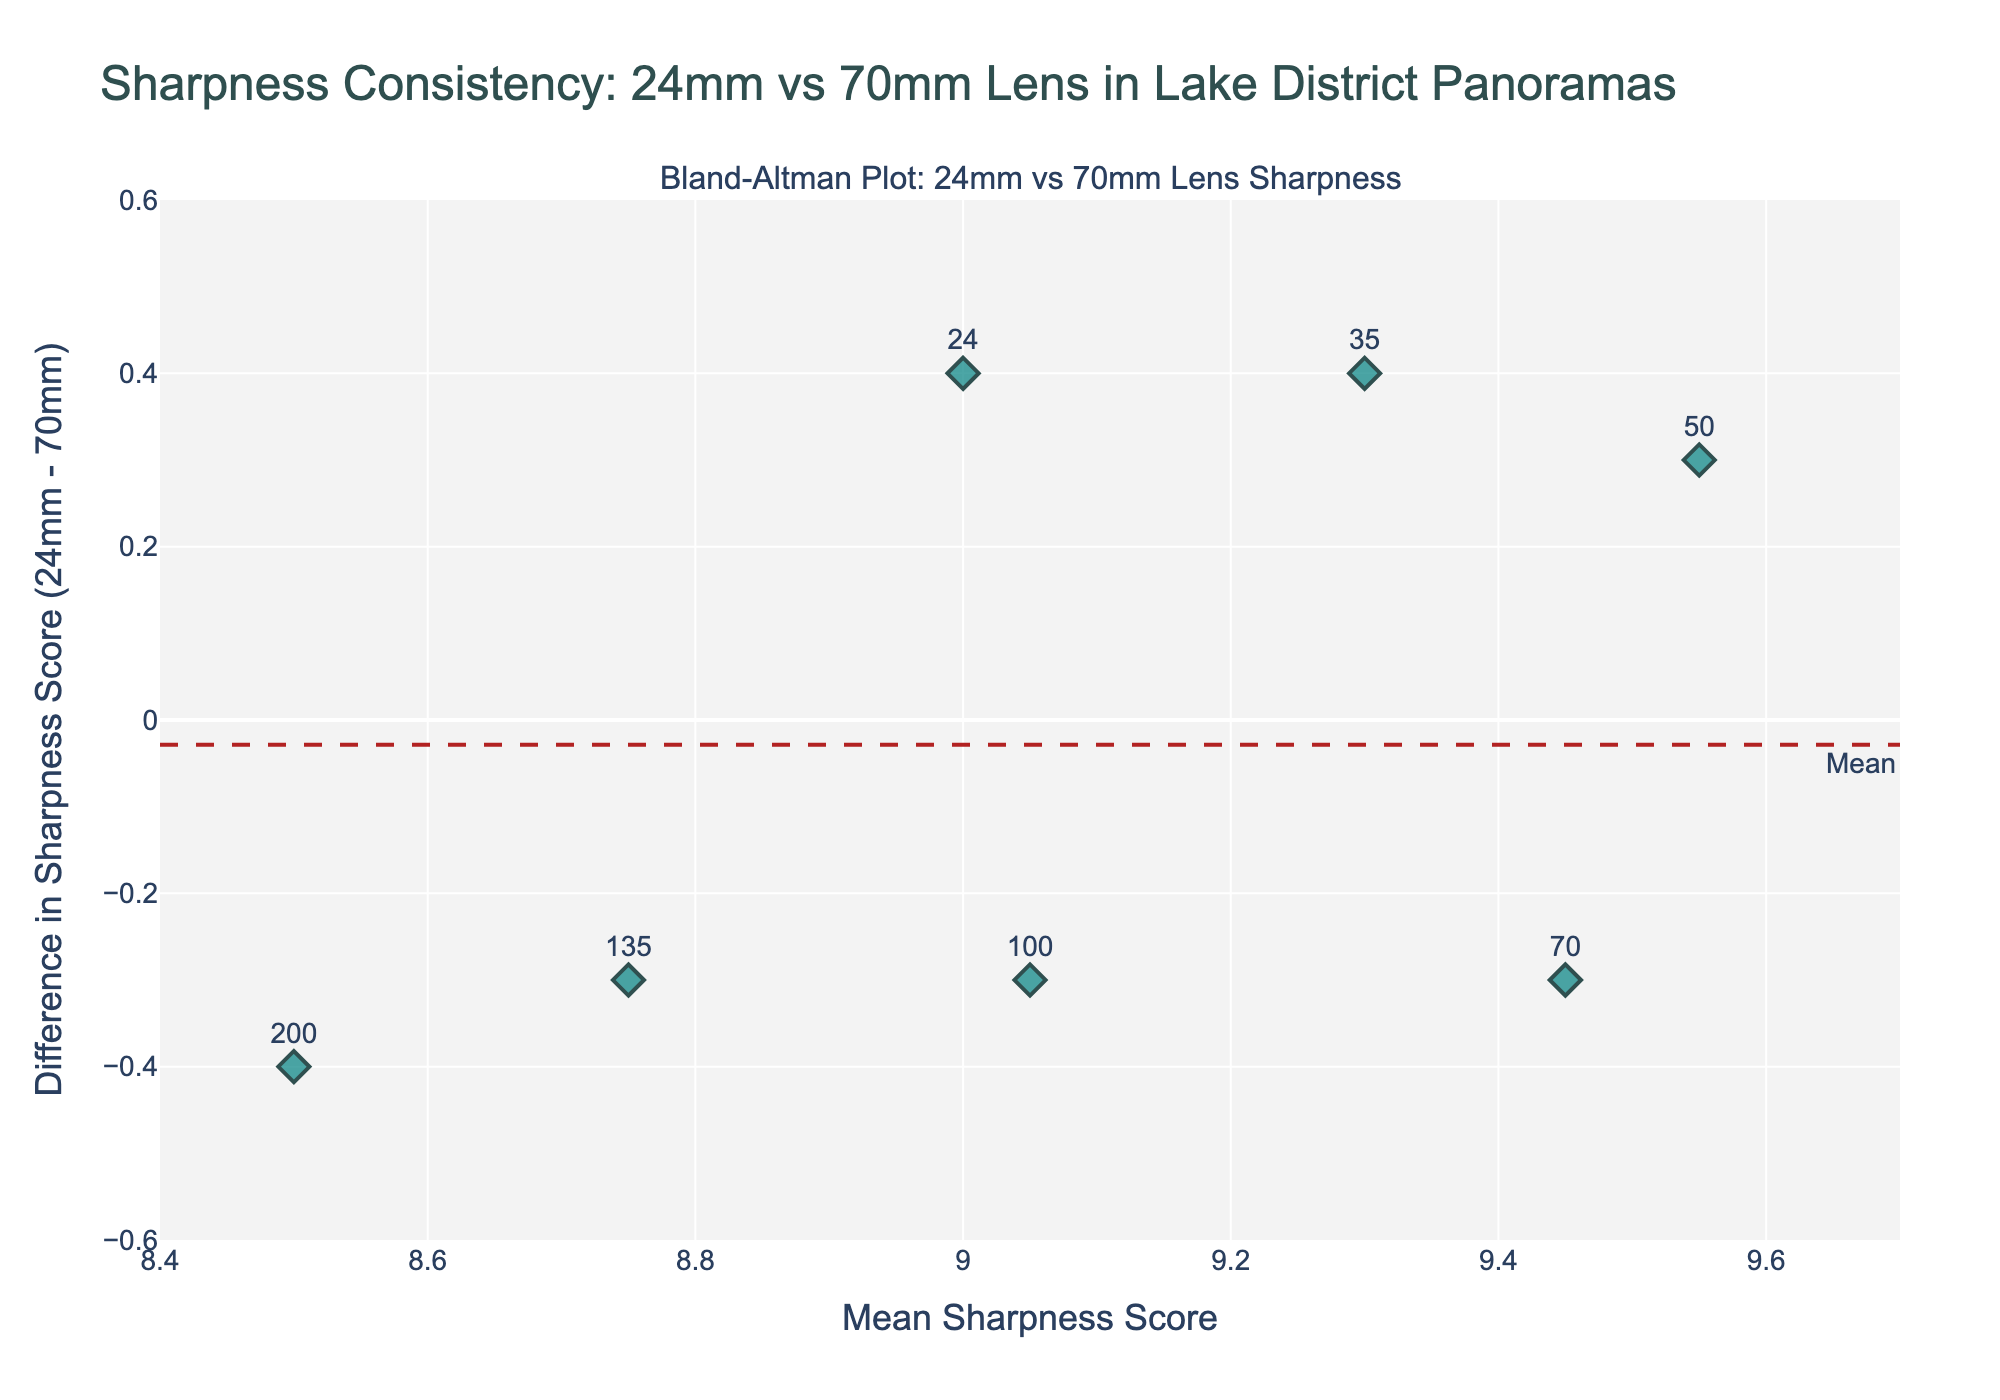What's the title of the figure? The title of the figure is generally found at the top of the plot, typically in bold or larger font size. It usually provides a clear indication of what the plot represents.
Answer: Sharpness Consistency: 24mm vs 70mm Lens in Lake District Panoramas What do the x-axis and y-axis represent? The x-axis title "Mean Sharpness Score" indicates it represents the average sharpness score across different focal lengths. The y-axis title "Difference in Sharpness Score (24mm - 70mm)" indicates it represents the difference in sharpness scores between the 24mm and 70mm lenses.
Answer: Mean Sharpness Score, Difference in Sharpness Score How many data points are plotted in the figure? There are 7 focal lengths (24, 35, 50, 70, 100, 135, and 200mm), and each is represented by a data point on the plot with their respective sharpness differences and mean values.
Answer: 7 What is the mean difference between the sharpness scores for the 24mm and 70mm lenses? The mean difference line can be identified by the annotation "Mean" on the plot. The y-value of this horizontal line gives the mean difference between the sharpness scores.
Answer: 0.04 What are the upper and lower limits of agreement? The upper and lower limits of agreement are shown by the dashed lines on the plot. The annotations "+1.96 SD" and "-1.96 SD" indicate these lines.
Answer: Approx. 0.56 and -0.48 Which data point has the highest mean sharpness score and what are its corresponding mean sharpness and difference in sharpness scores? By examining the x-axis (mean sharpness score) and y-axis (difference in sharpness score), we look for the highest point on the x-axis (9.55 for the 50mm focal length), and then find its corresponding y-coordinate.
Answer: 50mm, 9.55, 0.3 How does the difference in sharpness scores (24mm - 70mm) compare for the 24mm and 200mm focal lengths? First, locate the focal lengths 24mm and 200mm on the plot by their text labels. Then, compare the y-values (sharpness differences). The 24mm has a difference of 0.4 and the 200mm has a difference of -0.4.
Answer: 0.4 at 24mm, -0.4 at 200mm Is there a focal length where the difference in sharpness scores (24mm - 70mm) is zero? Look at the data points plotted along the y-axis and find if any point lies exactly on y=0. This would indicate that there is no difference between the sharpness scores at this focal length.
Answer: No What color and shape are used for the data points in the plot? The description specifies that the points are colored 'teal' and the shape is 'diamond'. These visual attributes help in identifying the data points on the plot.
Answer: Teal, diamond What is the sharpness score difference for the focal length with the smallest mean sharpness score, and what does it imply? Locate the smallest mean sharpness score on the x-axis (8.5 for 200mm) and find its corresponding y-value on the plot. The difference for the 200mm is approximately -0.4, indicating sharper images with the 70mm than with the 24mm at this focal length.
Answer: -0.4, 70mm sharper at 200mm focal length 